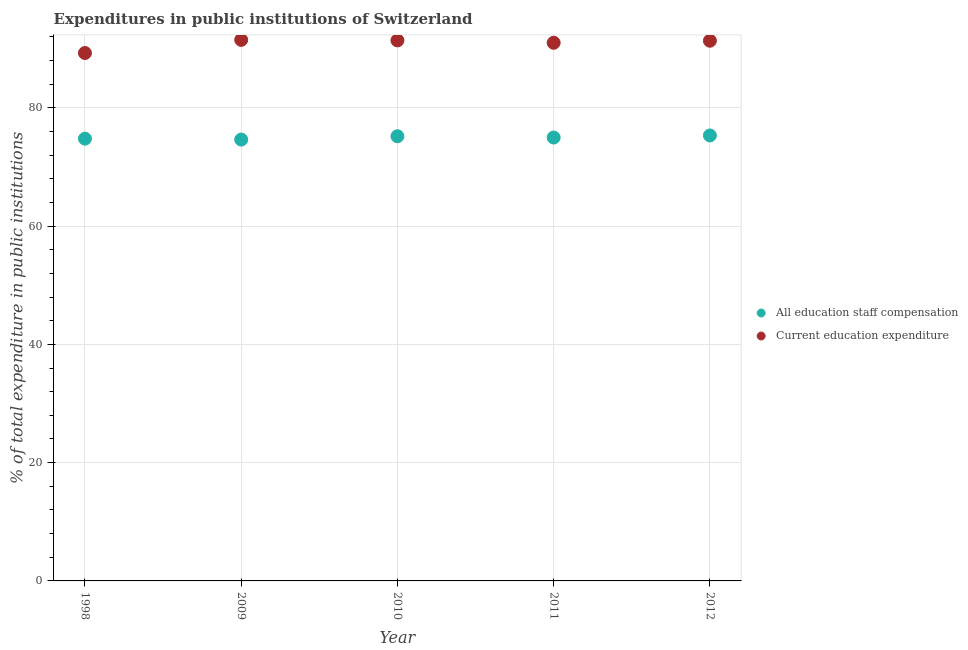How many different coloured dotlines are there?
Provide a short and direct response. 2. Is the number of dotlines equal to the number of legend labels?
Your response must be concise. Yes. What is the expenditure in education in 2010?
Your answer should be very brief. 91.4. Across all years, what is the maximum expenditure in education?
Your answer should be very brief. 91.49. Across all years, what is the minimum expenditure in education?
Your answer should be compact. 89.26. In which year was the expenditure in education maximum?
Provide a short and direct response. 2009. In which year was the expenditure in staff compensation minimum?
Your answer should be compact. 2009. What is the total expenditure in staff compensation in the graph?
Provide a succinct answer. 374.89. What is the difference between the expenditure in staff compensation in 1998 and that in 2012?
Your answer should be compact. -0.54. What is the difference between the expenditure in education in 2012 and the expenditure in staff compensation in 1998?
Provide a succinct answer. 16.56. What is the average expenditure in staff compensation per year?
Provide a succinct answer. 74.98. In the year 1998, what is the difference between the expenditure in education and expenditure in staff compensation?
Give a very brief answer. 14.48. In how many years, is the expenditure in staff compensation greater than 20 %?
Offer a very short reply. 5. What is the ratio of the expenditure in education in 2009 to that in 2012?
Ensure brevity in your answer.  1. What is the difference between the highest and the second highest expenditure in staff compensation?
Provide a succinct answer. 0.13. What is the difference between the highest and the lowest expenditure in education?
Your answer should be compact. 2.23. Is the sum of the expenditure in education in 2009 and 2011 greater than the maximum expenditure in staff compensation across all years?
Ensure brevity in your answer.  Yes. How many dotlines are there?
Your answer should be very brief. 2. How many years are there in the graph?
Your answer should be compact. 5. What is the difference between two consecutive major ticks on the Y-axis?
Your answer should be compact. 20. Are the values on the major ticks of Y-axis written in scientific E-notation?
Give a very brief answer. No. Does the graph contain grids?
Offer a terse response. Yes. Where does the legend appear in the graph?
Your response must be concise. Center right. How many legend labels are there?
Your answer should be very brief. 2. What is the title of the graph?
Keep it short and to the point. Expenditures in public institutions of Switzerland. Does "Personal remittances" appear as one of the legend labels in the graph?
Ensure brevity in your answer.  No. What is the label or title of the X-axis?
Give a very brief answer. Year. What is the label or title of the Y-axis?
Give a very brief answer. % of total expenditure in public institutions. What is the % of total expenditure in public institutions in All education staff compensation in 1998?
Provide a succinct answer. 74.78. What is the % of total expenditure in public institutions of Current education expenditure in 1998?
Keep it short and to the point. 89.26. What is the % of total expenditure in public institutions of All education staff compensation in 2009?
Offer a terse response. 74.63. What is the % of total expenditure in public institutions of Current education expenditure in 2009?
Offer a very short reply. 91.49. What is the % of total expenditure in public institutions in All education staff compensation in 2010?
Your answer should be compact. 75.19. What is the % of total expenditure in public institutions of Current education expenditure in 2010?
Your answer should be compact. 91.4. What is the % of total expenditure in public institutions of All education staff compensation in 2011?
Offer a terse response. 74.97. What is the % of total expenditure in public institutions in Current education expenditure in 2011?
Offer a very short reply. 90.99. What is the % of total expenditure in public institutions of All education staff compensation in 2012?
Provide a short and direct response. 75.32. What is the % of total expenditure in public institutions in Current education expenditure in 2012?
Make the answer very short. 91.34. Across all years, what is the maximum % of total expenditure in public institutions of All education staff compensation?
Your response must be concise. 75.32. Across all years, what is the maximum % of total expenditure in public institutions in Current education expenditure?
Ensure brevity in your answer.  91.49. Across all years, what is the minimum % of total expenditure in public institutions of All education staff compensation?
Your answer should be compact. 74.63. Across all years, what is the minimum % of total expenditure in public institutions in Current education expenditure?
Keep it short and to the point. 89.26. What is the total % of total expenditure in public institutions in All education staff compensation in the graph?
Keep it short and to the point. 374.89. What is the total % of total expenditure in public institutions in Current education expenditure in the graph?
Your answer should be very brief. 454.47. What is the difference between the % of total expenditure in public institutions of All education staff compensation in 1998 and that in 2009?
Offer a very short reply. 0.15. What is the difference between the % of total expenditure in public institutions of Current education expenditure in 1998 and that in 2009?
Keep it short and to the point. -2.23. What is the difference between the % of total expenditure in public institutions of All education staff compensation in 1998 and that in 2010?
Your response must be concise. -0.41. What is the difference between the % of total expenditure in public institutions in Current education expenditure in 1998 and that in 2010?
Ensure brevity in your answer.  -2.13. What is the difference between the % of total expenditure in public institutions in All education staff compensation in 1998 and that in 2011?
Your answer should be very brief. -0.19. What is the difference between the % of total expenditure in public institutions of Current education expenditure in 1998 and that in 2011?
Your answer should be compact. -1.73. What is the difference between the % of total expenditure in public institutions of All education staff compensation in 1998 and that in 2012?
Your answer should be compact. -0.54. What is the difference between the % of total expenditure in public institutions of Current education expenditure in 1998 and that in 2012?
Offer a very short reply. -2.08. What is the difference between the % of total expenditure in public institutions of All education staff compensation in 2009 and that in 2010?
Keep it short and to the point. -0.56. What is the difference between the % of total expenditure in public institutions in Current education expenditure in 2009 and that in 2010?
Provide a succinct answer. 0.09. What is the difference between the % of total expenditure in public institutions of All education staff compensation in 2009 and that in 2011?
Your answer should be compact. -0.34. What is the difference between the % of total expenditure in public institutions in Current education expenditure in 2009 and that in 2011?
Your answer should be compact. 0.49. What is the difference between the % of total expenditure in public institutions in All education staff compensation in 2009 and that in 2012?
Keep it short and to the point. -0.69. What is the difference between the % of total expenditure in public institutions in Current education expenditure in 2009 and that in 2012?
Make the answer very short. 0.15. What is the difference between the % of total expenditure in public institutions of All education staff compensation in 2010 and that in 2011?
Provide a short and direct response. 0.22. What is the difference between the % of total expenditure in public institutions in Current education expenditure in 2010 and that in 2011?
Provide a succinct answer. 0.4. What is the difference between the % of total expenditure in public institutions of All education staff compensation in 2010 and that in 2012?
Offer a terse response. -0.13. What is the difference between the % of total expenditure in public institutions of Current education expenditure in 2010 and that in 2012?
Provide a short and direct response. 0.06. What is the difference between the % of total expenditure in public institutions of All education staff compensation in 2011 and that in 2012?
Your response must be concise. -0.35. What is the difference between the % of total expenditure in public institutions in Current education expenditure in 2011 and that in 2012?
Offer a very short reply. -0.35. What is the difference between the % of total expenditure in public institutions of All education staff compensation in 1998 and the % of total expenditure in public institutions of Current education expenditure in 2009?
Your response must be concise. -16.71. What is the difference between the % of total expenditure in public institutions in All education staff compensation in 1998 and the % of total expenditure in public institutions in Current education expenditure in 2010?
Ensure brevity in your answer.  -16.62. What is the difference between the % of total expenditure in public institutions of All education staff compensation in 1998 and the % of total expenditure in public institutions of Current education expenditure in 2011?
Keep it short and to the point. -16.21. What is the difference between the % of total expenditure in public institutions in All education staff compensation in 1998 and the % of total expenditure in public institutions in Current education expenditure in 2012?
Give a very brief answer. -16.56. What is the difference between the % of total expenditure in public institutions in All education staff compensation in 2009 and the % of total expenditure in public institutions in Current education expenditure in 2010?
Your response must be concise. -16.77. What is the difference between the % of total expenditure in public institutions of All education staff compensation in 2009 and the % of total expenditure in public institutions of Current education expenditure in 2011?
Keep it short and to the point. -16.36. What is the difference between the % of total expenditure in public institutions of All education staff compensation in 2009 and the % of total expenditure in public institutions of Current education expenditure in 2012?
Your response must be concise. -16.71. What is the difference between the % of total expenditure in public institutions of All education staff compensation in 2010 and the % of total expenditure in public institutions of Current education expenditure in 2011?
Make the answer very short. -15.8. What is the difference between the % of total expenditure in public institutions of All education staff compensation in 2010 and the % of total expenditure in public institutions of Current education expenditure in 2012?
Your answer should be compact. -16.15. What is the difference between the % of total expenditure in public institutions of All education staff compensation in 2011 and the % of total expenditure in public institutions of Current education expenditure in 2012?
Provide a short and direct response. -16.37. What is the average % of total expenditure in public institutions of All education staff compensation per year?
Your answer should be very brief. 74.98. What is the average % of total expenditure in public institutions in Current education expenditure per year?
Make the answer very short. 90.89. In the year 1998, what is the difference between the % of total expenditure in public institutions in All education staff compensation and % of total expenditure in public institutions in Current education expenditure?
Make the answer very short. -14.48. In the year 2009, what is the difference between the % of total expenditure in public institutions of All education staff compensation and % of total expenditure in public institutions of Current education expenditure?
Give a very brief answer. -16.86. In the year 2010, what is the difference between the % of total expenditure in public institutions of All education staff compensation and % of total expenditure in public institutions of Current education expenditure?
Keep it short and to the point. -16.2. In the year 2011, what is the difference between the % of total expenditure in public institutions in All education staff compensation and % of total expenditure in public institutions in Current education expenditure?
Ensure brevity in your answer.  -16.02. In the year 2012, what is the difference between the % of total expenditure in public institutions of All education staff compensation and % of total expenditure in public institutions of Current education expenditure?
Give a very brief answer. -16.02. What is the ratio of the % of total expenditure in public institutions in Current education expenditure in 1998 to that in 2009?
Your response must be concise. 0.98. What is the ratio of the % of total expenditure in public institutions of Current education expenditure in 1998 to that in 2010?
Your response must be concise. 0.98. What is the ratio of the % of total expenditure in public institutions in Current education expenditure in 1998 to that in 2011?
Give a very brief answer. 0.98. What is the ratio of the % of total expenditure in public institutions in Current education expenditure in 1998 to that in 2012?
Give a very brief answer. 0.98. What is the ratio of the % of total expenditure in public institutions in Current education expenditure in 2009 to that in 2010?
Make the answer very short. 1. What is the ratio of the % of total expenditure in public institutions of All education staff compensation in 2009 to that in 2011?
Provide a short and direct response. 1. What is the ratio of the % of total expenditure in public institutions in Current education expenditure in 2009 to that in 2011?
Provide a short and direct response. 1.01. What is the ratio of the % of total expenditure in public institutions of All education staff compensation in 2009 to that in 2012?
Provide a short and direct response. 0.99. What is the ratio of the % of total expenditure in public institutions of Current education expenditure in 2009 to that in 2012?
Offer a terse response. 1. What is the ratio of the % of total expenditure in public institutions of All education staff compensation in 2010 to that in 2012?
Your answer should be compact. 1. What is the ratio of the % of total expenditure in public institutions of Current education expenditure in 2011 to that in 2012?
Provide a short and direct response. 1. What is the difference between the highest and the second highest % of total expenditure in public institutions of All education staff compensation?
Your answer should be very brief. 0.13. What is the difference between the highest and the second highest % of total expenditure in public institutions of Current education expenditure?
Give a very brief answer. 0.09. What is the difference between the highest and the lowest % of total expenditure in public institutions in All education staff compensation?
Give a very brief answer. 0.69. What is the difference between the highest and the lowest % of total expenditure in public institutions of Current education expenditure?
Provide a succinct answer. 2.23. 